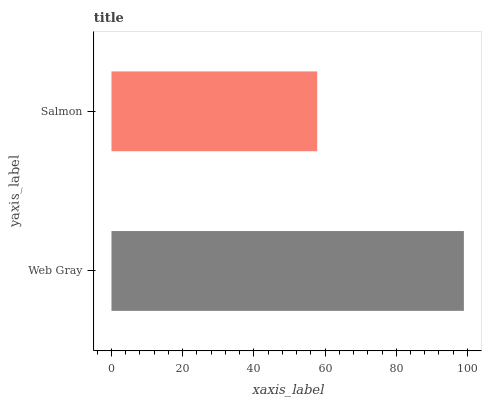Is Salmon the minimum?
Answer yes or no. Yes. Is Web Gray the maximum?
Answer yes or no. Yes. Is Salmon the maximum?
Answer yes or no. No. Is Web Gray greater than Salmon?
Answer yes or no. Yes. Is Salmon less than Web Gray?
Answer yes or no. Yes. Is Salmon greater than Web Gray?
Answer yes or no. No. Is Web Gray less than Salmon?
Answer yes or no. No. Is Web Gray the high median?
Answer yes or no. Yes. Is Salmon the low median?
Answer yes or no. Yes. Is Salmon the high median?
Answer yes or no. No. Is Web Gray the low median?
Answer yes or no. No. 